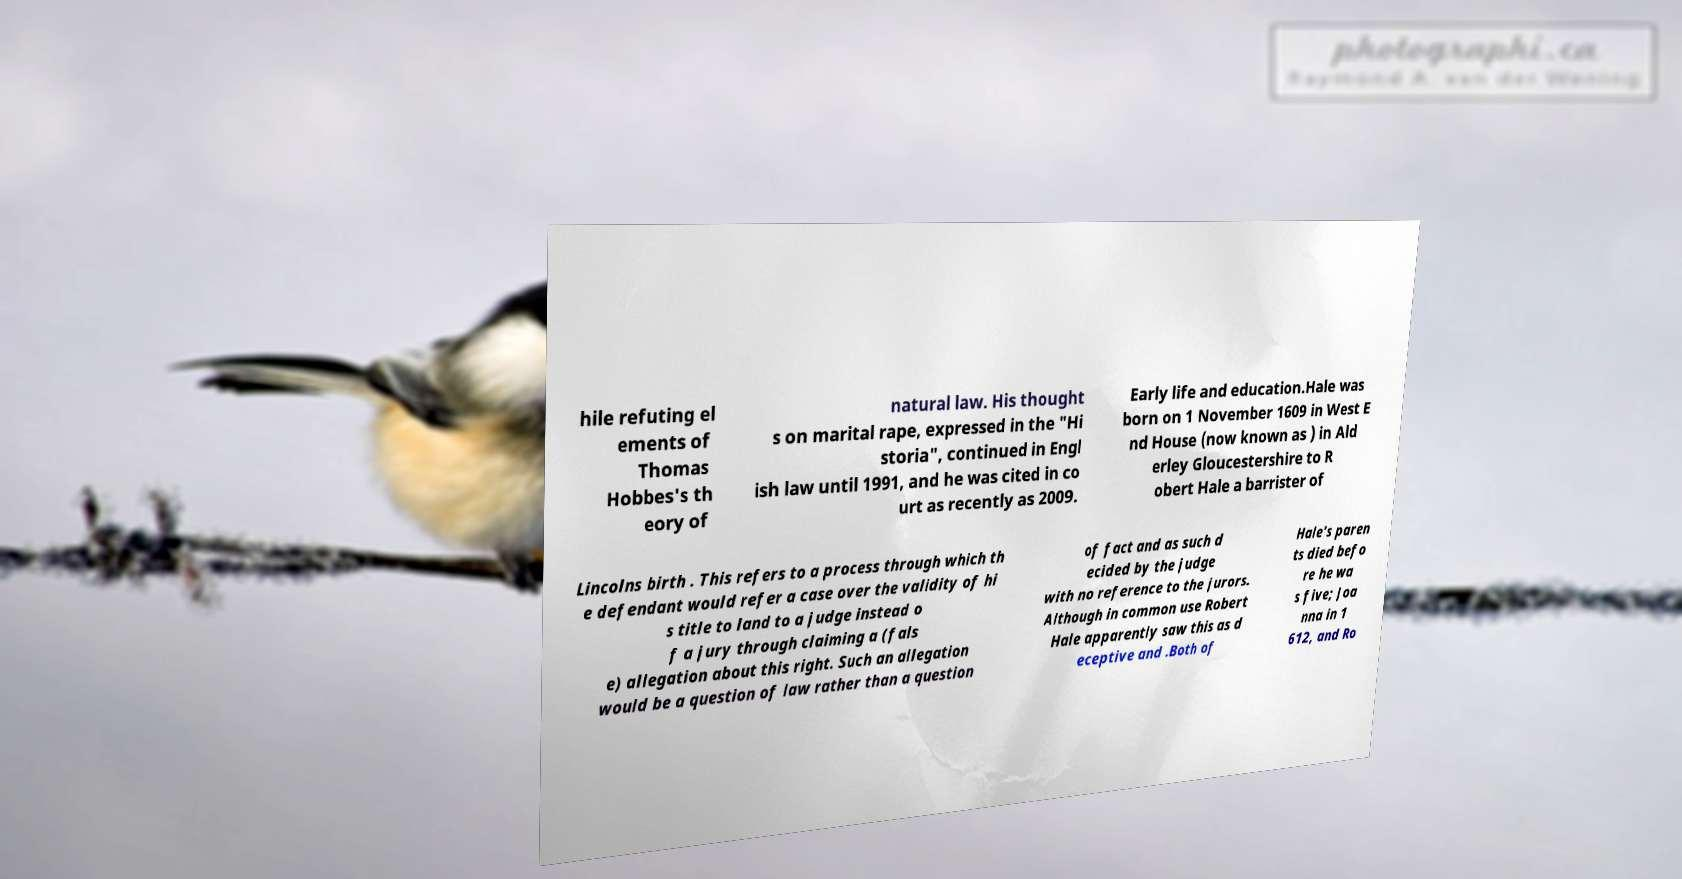Can you read and provide the text displayed in the image?This photo seems to have some interesting text. Can you extract and type it out for me? hile refuting el ements of Thomas Hobbes's th eory of natural law. His thought s on marital rape, expressed in the "Hi storia", continued in Engl ish law until 1991, and he was cited in co urt as recently as 2009. Early life and education.Hale was born on 1 November 1609 in West E nd House (now known as ) in Ald erley Gloucestershire to R obert Hale a barrister of Lincolns birth . This refers to a process through which th e defendant would refer a case over the validity of hi s title to land to a judge instead o f a jury through claiming a (fals e) allegation about this right. Such an allegation would be a question of law rather than a question of fact and as such d ecided by the judge with no reference to the jurors. Although in common use Robert Hale apparently saw this as d eceptive and .Both of Hale's paren ts died befo re he wa s five; Joa nna in 1 612, and Ro 